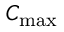<formula> <loc_0><loc_0><loc_500><loc_500>C _ { \max }</formula> 